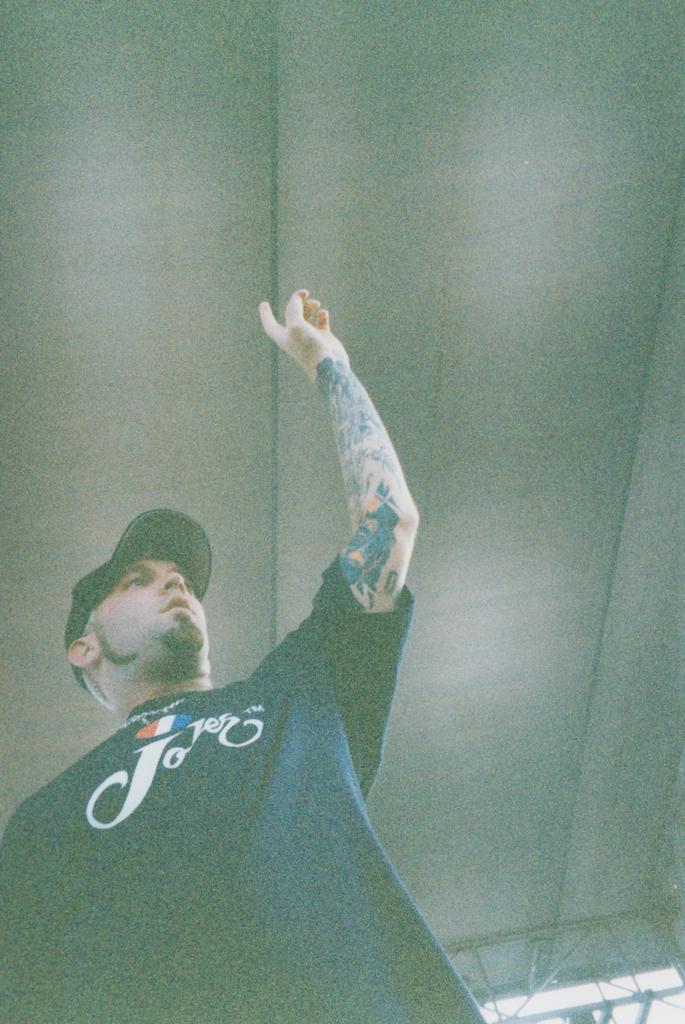Can you describe this image briefly? In this image we can see a person. On the backside we can see a roof. 